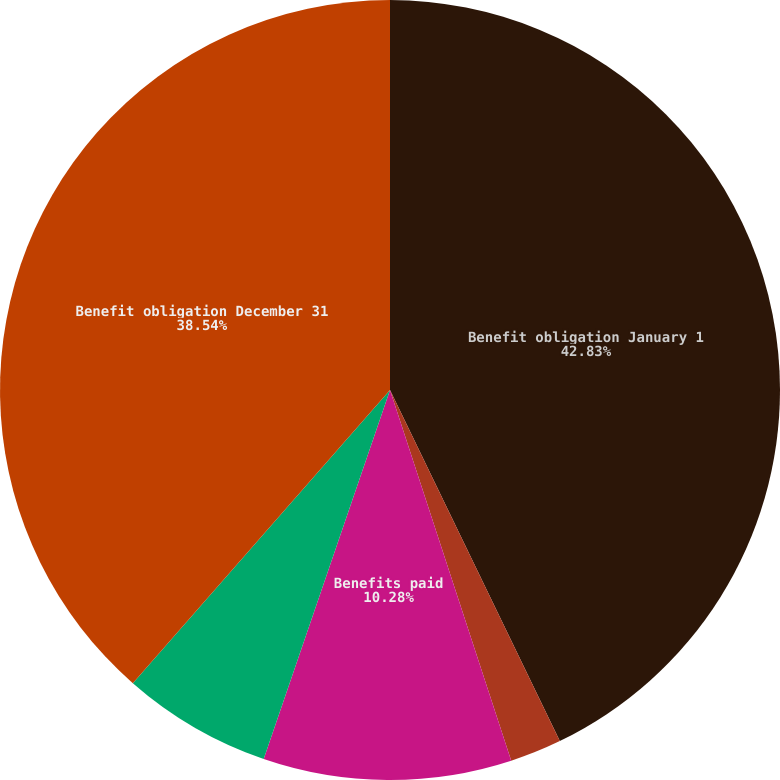Convert chart to OTSL. <chart><loc_0><loc_0><loc_500><loc_500><pie_chart><fcel>Benefit obligation January 1<fcel>Interest cost<fcel>Benefits paid<fcel>Participant contributions<fcel>Benefit obligation December 31<nl><fcel>42.83%<fcel>2.14%<fcel>10.28%<fcel>6.21%<fcel>38.54%<nl></chart> 